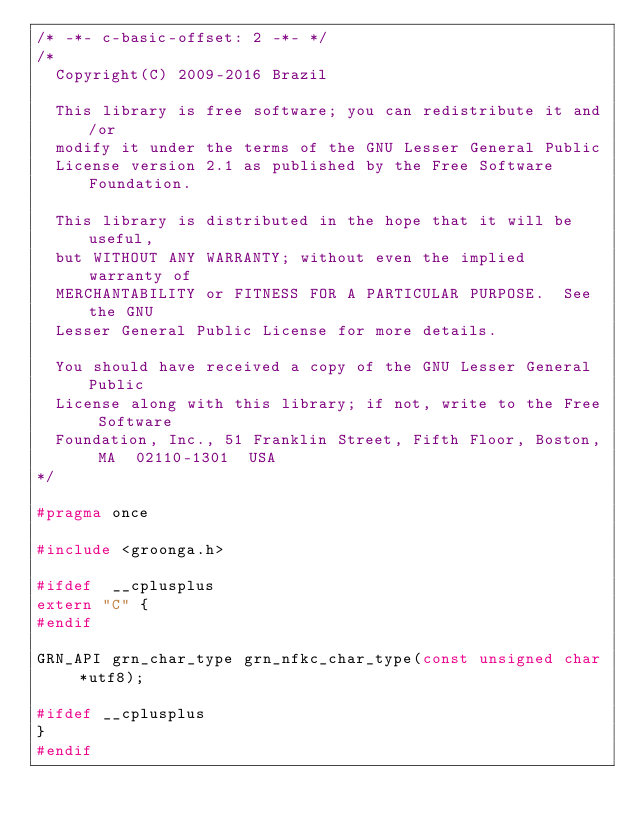<code> <loc_0><loc_0><loc_500><loc_500><_C_>/* -*- c-basic-offset: 2 -*- */
/*
  Copyright(C) 2009-2016 Brazil

  This library is free software; you can redistribute it and/or
  modify it under the terms of the GNU Lesser General Public
  License version 2.1 as published by the Free Software Foundation.

  This library is distributed in the hope that it will be useful,
  but WITHOUT ANY WARRANTY; without even the implied warranty of
  MERCHANTABILITY or FITNESS FOR A PARTICULAR PURPOSE.  See the GNU
  Lesser General Public License for more details.

  You should have received a copy of the GNU Lesser General Public
  License along with this library; if not, write to the Free Software
  Foundation, Inc., 51 Franklin Street, Fifth Floor, Boston, MA  02110-1301  USA
*/

#pragma once

#include <groonga.h>

#ifdef	__cplusplus
extern "C" {
#endif

GRN_API grn_char_type grn_nfkc_char_type(const unsigned char *utf8);

#ifdef __cplusplus
}
#endif
</code> 